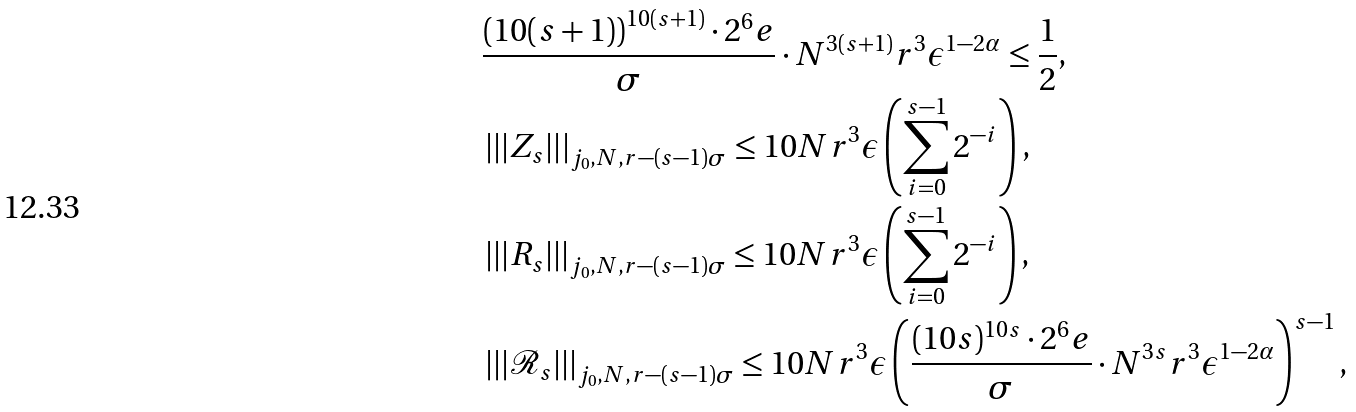Convert formula to latex. <formula><loc_0><loc_0><loc_500><loc_500>& \frac { \left ( 1 0 ( s + 1 ) \right ) ^ { 1 0 ( s + 1 ) } \cdot 2 ^ { 6 } e } { \sigma } \cdot N ^ { 3 ( s + 1 ) } r ^ { 3 } \epsilon ^ { 1 - 2 \alpha } \leq \frac { 1 } { 2 } , \\ & \left | \left | \left | Z _ { s } \right | \right | \right | _ { j _ { 0 } , N , r - ( s - 1 ) \sigma } \leq 1 0 N r ^ { 3 } \epsilon \left ( \sum _ { i = 0 } ^ { s - 1 } 2 ^ { - i } \right ) , \\ & \left | \left | \left | R _ { s } \right | \right | \right | _ { j _ { 0 } , N , r - ( s - 1 ) \sigma } \leq 1 0 N r ^ { 3 } \epsilon \left ( \sum _ { i = 0 } ^ { s - 1 } 2 ^ { - i } \right ) , \\ & \left | \left | \left | \mathcal { R } _ { s } \right | \right | \right | _ { j _ { 0 } , N , r - ( s - 1 ) \sigma } \leq 1 0 N r ^ { 3 } \epsilon \left ( \frac { ( 1 0 s ) ^ { 1 0 s } \cdot 2 ^ { 6 } e } { \sigma } \cdot N ^ { 3 s } r ^ { 3 } \epsilon ^ { 1 - 2 \alpha } \right ) ^ { s - 1 } ,</formula> 